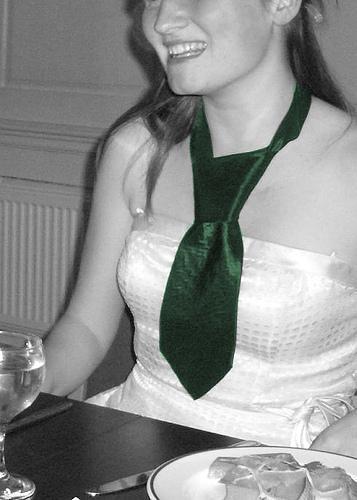How many people are pictured?
Give a very brief answer. 1. 